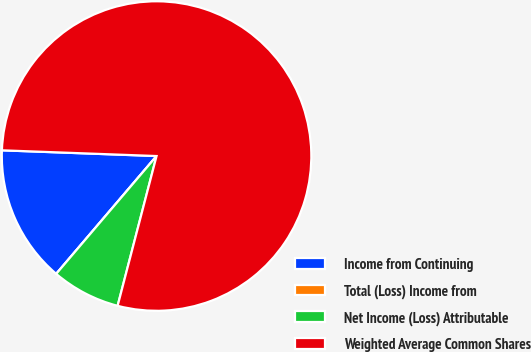Convert chart to OTSL. <chart><loc_0><loc_0><loc_500><loc_500><pie_chart><fcel>Income from Continuing<fcel>Total (Loss) Income from<fcel>Net Income (Loss) Attributable<fcel>Weighted Average Common Shares<nl><fcel>14.36%<fcel>0.0%<fcel>7.18%<fcel>78.46%<nl></chart> 